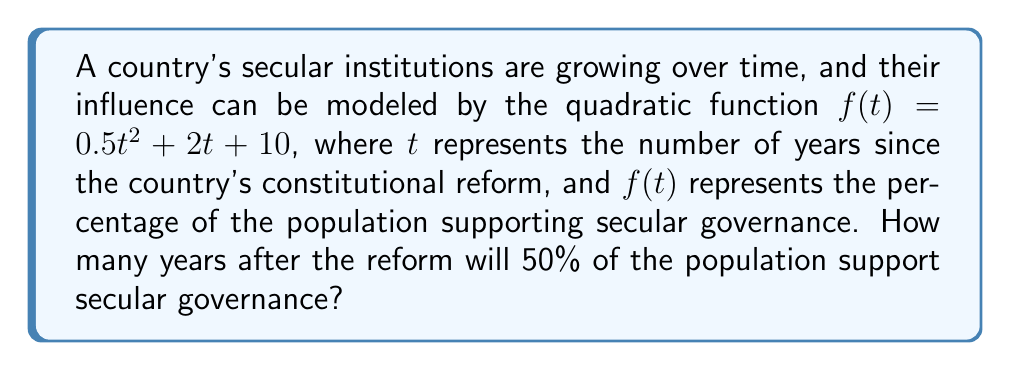Can you solve this math problem? To solve this problem, we need to follow these steps:

1) We're looking for the time $t$ when $f(t) = 50$. This can be expressed as an equation:

   $0.5t^2 + 2t + 10 = 50$

2) Subtract 50 from both sides to get the equation in standard form:

   $0.5t^2 + 2t - 40 = 0$

3) This is a quadratic equation. We can solve it using the quadratic formula:

   $t = \frac{-b \pm \sqrt{b^2 - 4ac}}{2a}$

   where $a = 0.5$, $b = 2$, and $c = -40$

4) Substituting these values:

   $t = \frac{-2 \pm \sqrt{2^2 - 4(0.5)(-40)}}{2(0.5)}$

5) Simplify under the square root:

   $t = \frac{-2 \pm \sqrt{4 + 80}}{1} = -2 \pm \sqrt{84}$

6) Simplify further:

   $t = -2 \pm 9.17$

7) This gives us two solutions:

   $t_1 = -2 + 9.17 = 7.17$
   $t_2 = -2 - 9.17 = -11.17$

8) Since time cannot be negative in this context, we discard the negative solution.

Therefore, approximately 7.17 years after the constitutional reform, 50% of the population will support secular governance.
Answer: 7.17 years 